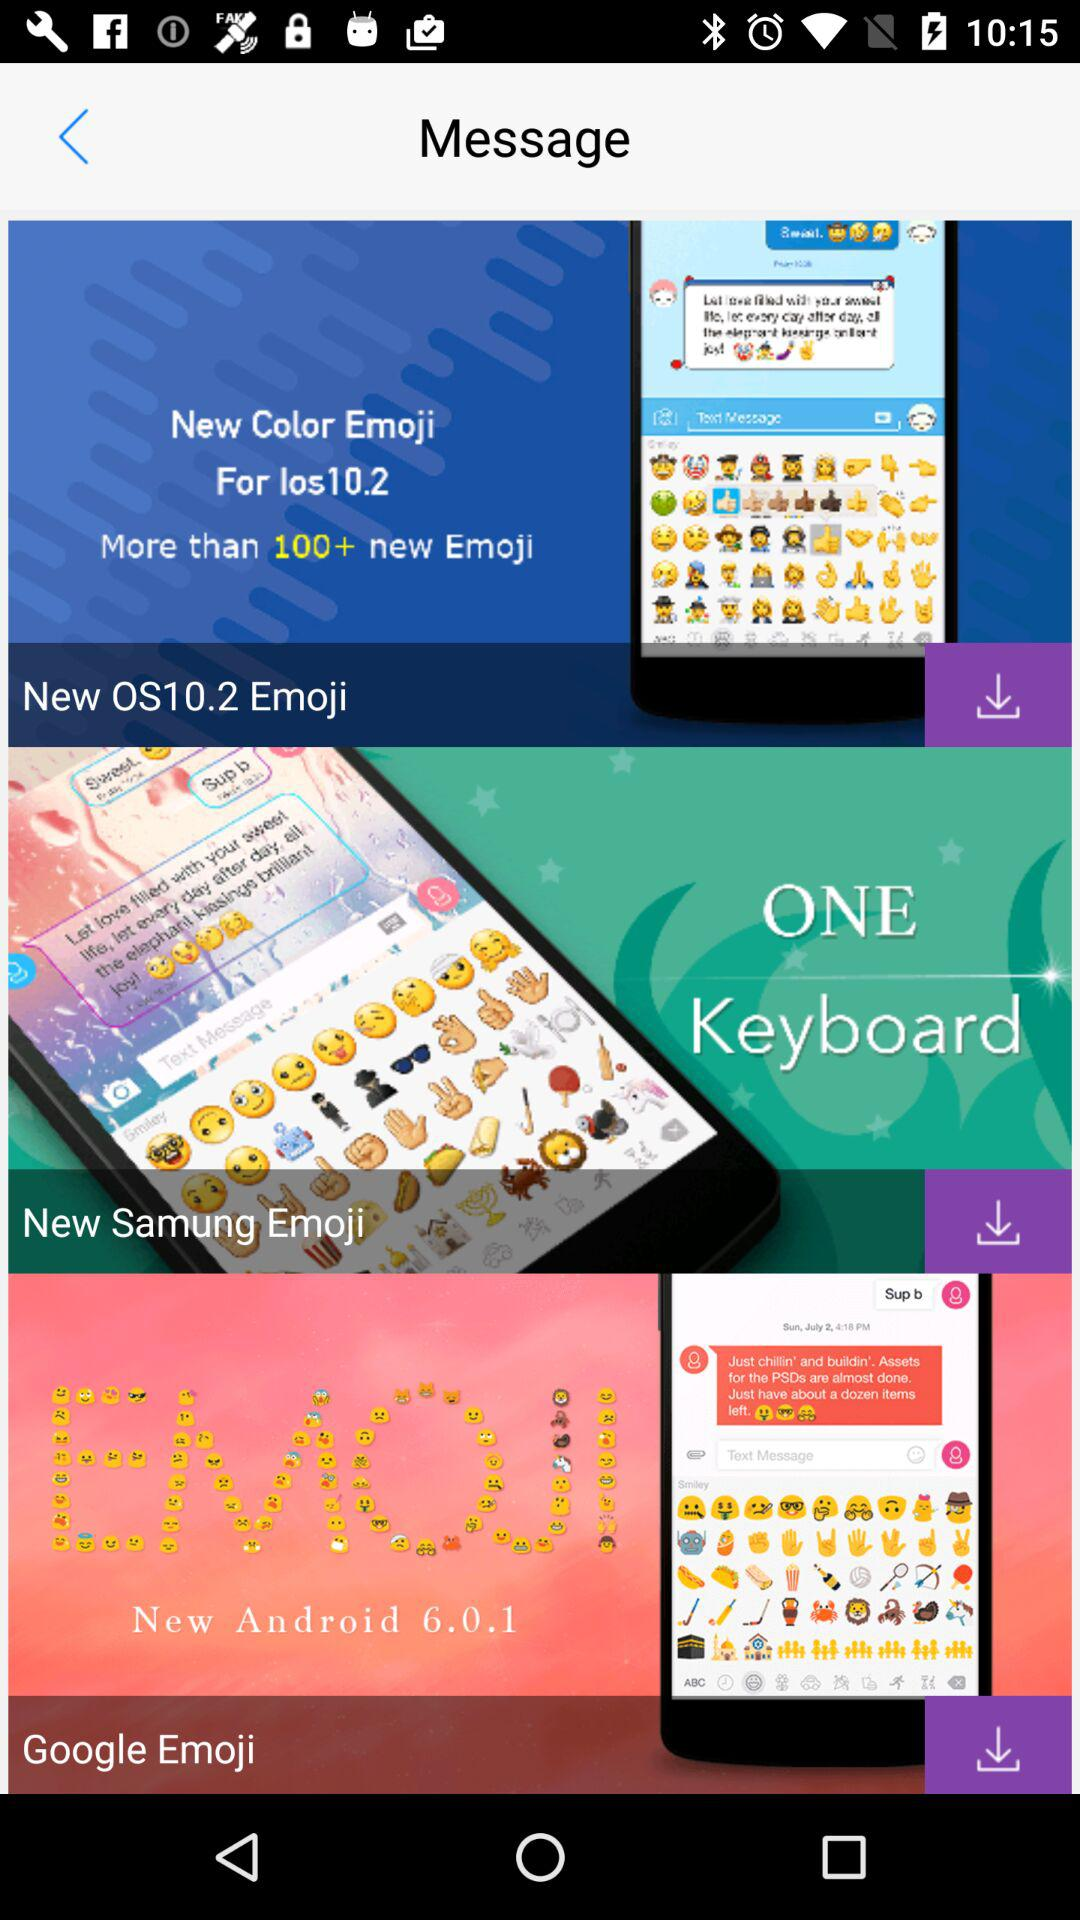How many messages are downloaded?
When the provided information is insufficient, respond with <no answer>. <no answer> 